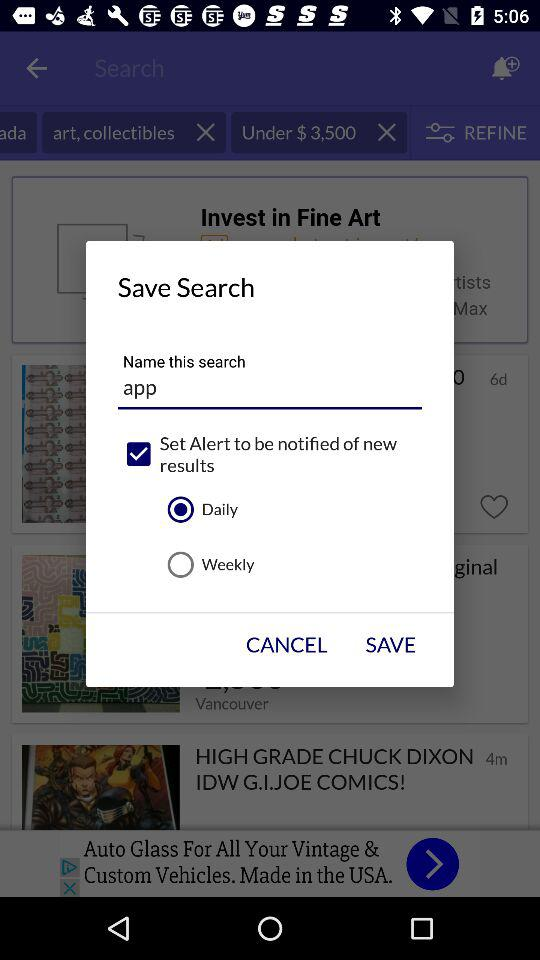What is the current location? The current location is Canada. 